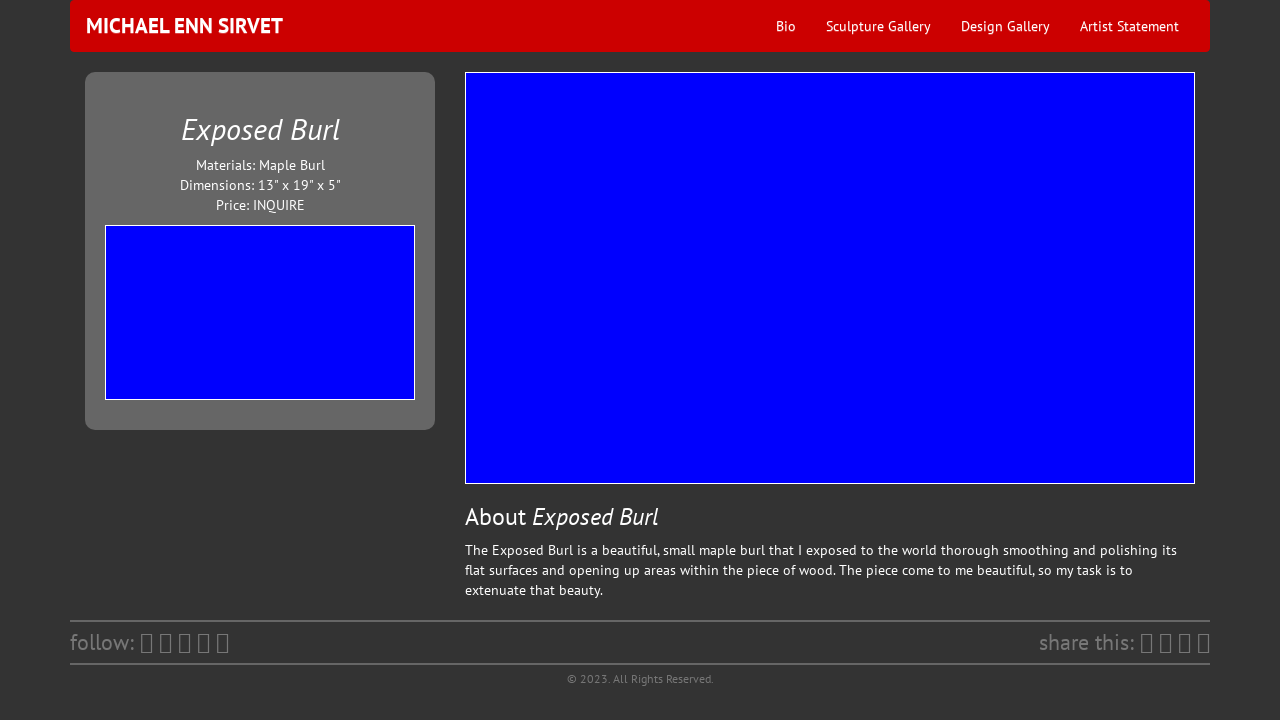Could you detail the process for assembling this website using HTML? Building a website like the one shown requires a structured approach, starting with defining the HTML skeleton which outlines the sections like the navigation bar, main content area, sidebar, and footer. Subsequently, one can link CSS stylesheets for visual styling and JavaScript for interactivity. Key HTML tags would include <nav> for the navigation bar, <div> containers for different sections, and <img> for embedding images such as the artwork. CSS would be used to style these elements, as seen in the provided code, while ensuring responsive design for optimal display across devices. 